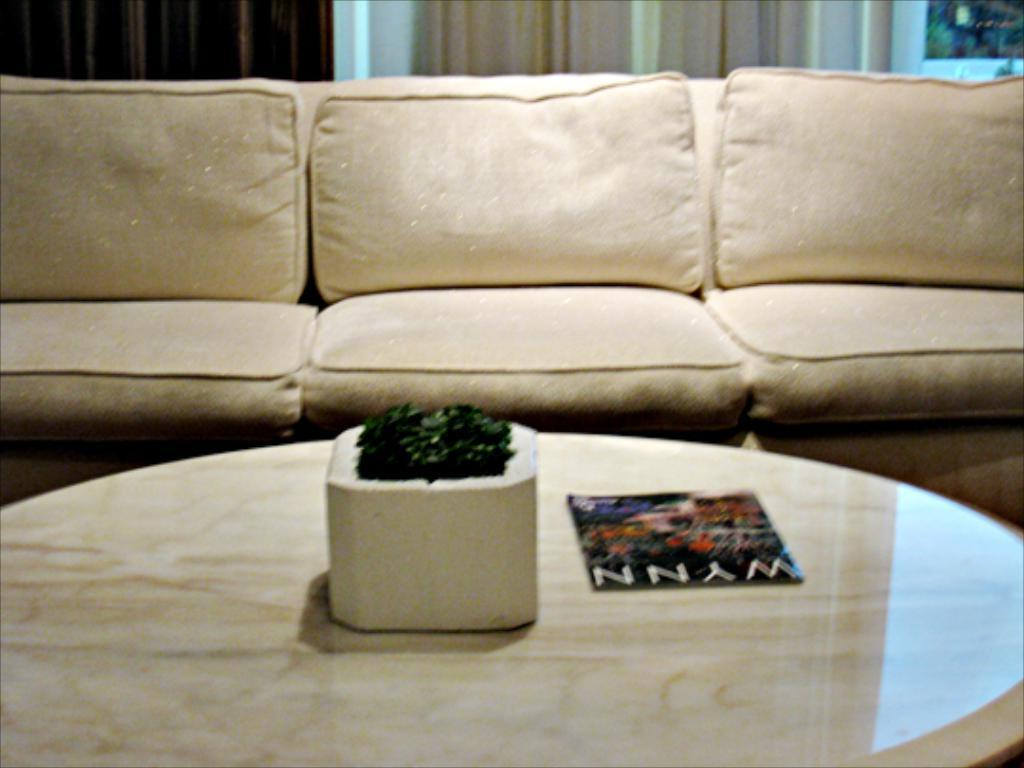What piece of furniture is in the image? There is a table in the image. What is on top of the table? There is a flower pot and a magazine on the table. What type of seating is visible in the image? There is a sofa behind the table. What can be seen on the backside of the image? There are curtains on the backside of the image. What type of waves can be seen crashing on the shore in the image? There are no waves or shore visible in the image; it features a table, a flower pot, a magazine, a sofa, and curtains. What color is the gold statue in the image? There is no gold statue present in the image. 